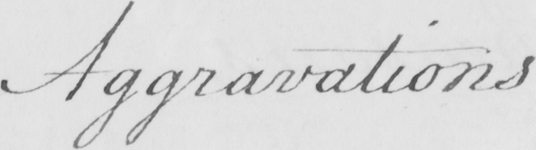Please provide the text content of this handwritten line. Aggravations . 